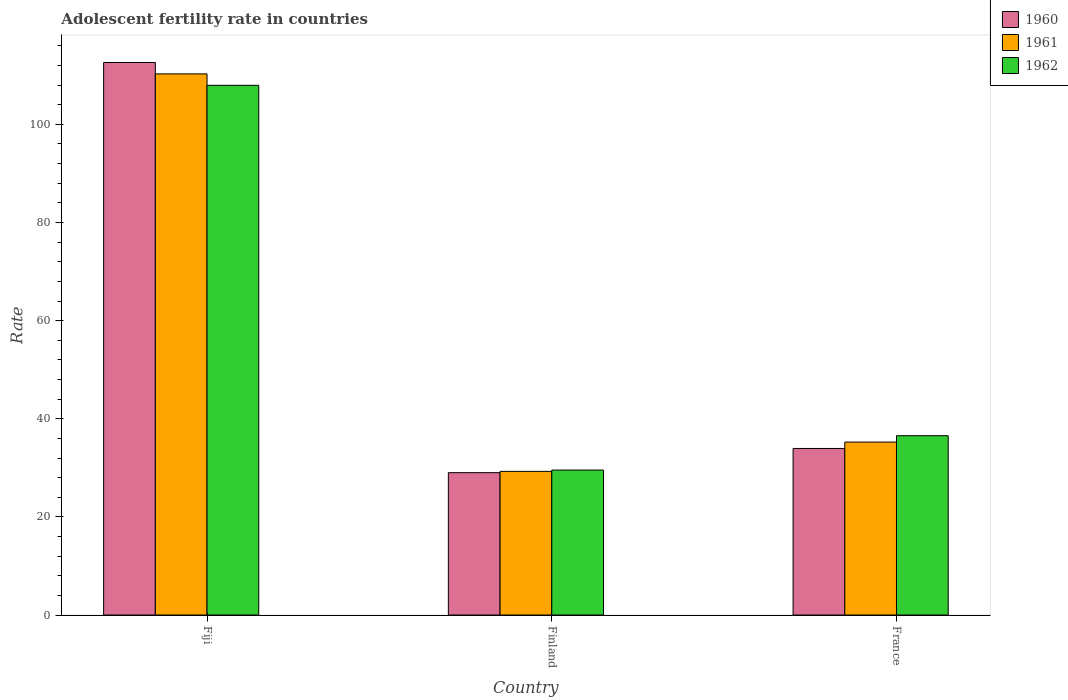How many different coloured bars are there?
Give a very brief answer. 3. How many groups of bars are there?
Offer a very short reply. 3. Are the number of bars on each tick of the X-axis equal?
Your answer should be very brief. Yes. What is the label of the 3rd group of bars from the left?
Make the answer very short. France. In how many cases, is the number of bars for a given country not equal to the number of legend labels?
Your answer should be very brief. 0. What is the adolescent fertility rate in 1960 in France?
Offer a terse response. 33.95. Across all countries, what is the maximum adolescent fertility rate in 1960?
Provide a succinct answer. 112.61. Across all countries, what is the minimum adolescent fertility rate in 1960?
Offer a very short reply. 29.01. In which country was the adolescent fertility rate in 1961 maximum?
Offer a terse response. Fiji. In which country was the adolescent fertility rate in 1961 minimum?
Ensure brevity in your answer.  Finland. What is the total adolescent fertility rate in 1960 in the graph?
Offer a terse response. 175.57. What is the difference between the adolescent fertility rate in 1960 in Fiji and that in Finland?
Give a very brief answer. 83.6. What is the difference between the adolescent fertility rate in 1962 in Fiji and the adolescent fertility rate in 1961 in Finland?
Keep it short and to the point. 78.69. What is the average adolescent fertility rate in 1962 per country?
Your answer should be very brief. 58.02. What is the difference between the adolescent fertility rate of/in 1960 and adolescent fertility rate of/in 1961 in Fiji?
Your answer should be compact. 2.32. In how many countries, is the adolescent fertility rate in 1960 greater than 68?
Provide a succinct answer. 1. What is the ratio of the adolescent fertility rate in 1960 in Finland to that in France?
Your answer should be very brief. 0.85. Is the adolescent fertility rate in 1960 in Fiji less than that in Finland?
Keep it short and to the point. No. What is the difference between the highest and the second highest adolescent fertility rate in 1960?
Give a very brief answer. 78.66. What is the difference between the highest and the lowest adolescent fertility rate in 1961?
Your answer should be compact. 81.01. In how many countries, is the adolescent fertility rate in 1961 greater than the average adolescent fertility rate in 1961 taken over all countries?
Your response must be concise. 1. Is the sum of the adolescent fertility rate in 1961 in Fiji and Finland greater than the maximum adolescent fertility rate in 1960 across all countries?
Keep it short and to the point. Yes. Is it the case that in every country, the sum of the adolescent fertility rate in 1960 and adolescent fertility rate in 1962 is greater than the adolescent fertility rate in 1961?
Make the answer very short. Yes. How many countries are there in the graph?
Ensure brevity in your answer.  3. What is the difference between two consecutive major ticks on the Y-axis?
Make the answer very short. 20. Are the values on the major ticks of Y-axis written in scientific E-notation?
Your answer should be compact. No. Where does the legend appear in the graph?
Your answer should be compact. Top right. How are the legend labels stacked?
Offer a terse response. Vertical. What is the title of the graph?
Provide a short and direct response. Adolescent fertility rate in countries. What is the label or title of the X-axis?
Provide a succinct answer. Country. What is the label or title of the Y-axis?
Keep it short and to the point. Rate. What is the Rate in 1960 in Fiji?
Provide a succinct answer. 112.61. What is the Rate in 1961 in Fiji?
Your answer should be very brief. 110.29. What is the Rate in 1962 in Fiji?
Provide a succinct answer. 107.96. What is the Rate of 1960 in Finland?
Offer a very short reply. 29.01. What is the Rate of 1961 in Finland?
Offer a terse response. 29.28. What is the Rate in 1962 in Finland?
Give a very brief answer. 29.54. What is the Rate in 1960 in France?
Keep it short and to the point. 33.95. What is the Rate of 1961 in France?
Your response must be concise. 35.25. What is the Rate of 1962 in France?
Offer a very short reply. 36.55. Across all countries, what is the maximum Rate of 1960?
Your answer should be compact. 112.61. Across all countries, what is the maximum Rate in 1961?
Keep it short and to the point. 110.29. Across all countries, what is the maximum Rate of 1962?
Your response must be concise. 107.96. Across all countries, what is the minimum Rate in 1960?
Your answer should be compact. 29.01. Across all countries, what is the minimum Rate of 1961?
Keep it short and to the point. 29.28. Across all countries, what is the minimum Rate of 1962?
Your response must be concise. 29.54. What is the total Rate in 1960 in the graph?
Your response must be concise. 175.57. What is the total Rate in 1961 in the graph?
Offer a terse response. 174.81. What is the total Rate of 1962 in the graph?
Keep it short and to the point. 174.05. What is the difference between the Rate of 1960 in Fiji and that in Finland?
Make the answer very short. 83.6. What is the difference between the Rate of 1961 in Fiji and that in Finland?
Offer a very short reply. 81.01. What is the difference between the Rate of 1962 in Fiji and that in Finland?
Make the answer very short. 78.42. What is the difference between the Rate in 1960 in Fiji and that in France?
Keep it short and to the point. 78.66. What is the difference between the Rate in 1961 in Fiji and that in France?
Keep it short and to the point. 75.04. What is the difference between the Rate in 1962 in Fiji and that in France?
Your answer should be very brief. 71.42. What is the difference between the Rate of 1960 in Finland and that in France?
Provide a succinct answer. -4.93. What is the difference between the Rate in 1961 in Finland and that in France?
Make the answer very short. -5.97. What is the difference between the Rate in 1962 in Finland and that in France?
Your answer should be very brief. -7. What is the difference between the Rate in 1960 in Fiji and the Rate in 1961 in Finland?
Offer a very short reply. 83.33. What is the difference between the Rate of 1960 in Fiji and the Rate of 1962 in Finland?
Ensure brevity in your answer.  83.07. What is the difference between the Rate of 1961 in Fiji and the Rate of 1962 in Finland?
Provide a succinct answer. 80.75. What is the difference between the Rate of 1960 in Fiji and the Rate of 1961 in France?
Keep it short and to the point. 77.36. What is the difference between the Rate of 1960 in Fiji and the Rate of 1962 in France?
Your answer should be very brief. 76.06. What is the difference between the Rate in 1961 in Fiji and the Rate in 1962 in France?
Offer a terse response. 73.74. What is the difference between the Rate in 1960 in Finland and the Rate in 1961 in France?
Give a very brief answer. -6.23. What is the difference between the Rate of 1960 in Finland and the Rate of 1962 in France?
Keep it short and to the point. -7.53. What is the difference between the Rate of 1961 in Finland and the Rate of 1962 in France?
Your answer should be compact. -7.27. What is the average Rate of 1960 per country?
Offer a terse response. 58.52. What is the average Rate in 1961 per country?
Provide a short and direct response. 58.27. What is the average Rate in 1962 per country?
Your answer should be very brief. 58.02. What is the difference between the Rate in 1960 and Rate in 1961 in Fiji?
Make the answer very short. 2.32. What is the difference between the Rate of 1960 and Rate of 1962 in Fiji?
Your answer should be very brief. 4.65. What is the difference between the Rate in 1961 and Rate in 1962 in Fiji?
Give a very brief answer. 2.32. What is the difference between the Rate in 1960 and Rate in 1961 in Finland?
Make the answer very short. -0.26. What is the difference between the Rate of 1960 and Rate of 1962 in Finland?
Provide a short and direct response. -0.53. What is the difference between the Rate in 1961 and Rate in 1962 in Finland?
Ensure brevity in your answer.  -0.26. What is the difference between the Rate of 1960 and Rate of 1961 in France?
Offer a very short reply. -1.3. What is the difference between the Rate in 1960 and Rate in 1962 in France?
Your answer should be very brief. -2.6. What is the difference between the Rate in 1961 and Rate in 1962 in France?
Provide a succinct answer. -1.3. What is the ratio of the Rate of 1960 in Fiji to that in Finland?
Your answer should be compact. 3.88. What is the ratio of the Rate of 1961 in Fiji to that in Finland?
Offer a very short reply. 3.77. What is the ratio of the Rate in 1962 in Fiji to that in Finland?
Your answer should be very brief. 3.65. What is the ratio of the Rate in 1960 in Fiji to that in France?
Provide a short and direct response. 3.32. What is the ratio of the Rate in 1961 in Fiji to that in France?
Provide a short and direct response. 3.13. What is the ratio of the Rate of 1962 in Fiji to that in France?
Provide a succinct answer. 2.95. What is the ratio of the Rate of 1960 in Finland to that in France?
Offer a terse response. 0.85. What is the ratio of the Rate of 1961 in Finland to that in France?
Provide a short and direct response. 0.83. What is the ratio of the Rate in 1962 in Finland to that in France?
Keep it short and to the point. 0.81. What is the difference between the highest and the second highest Rate in 1960?
Keep it short and to the point. 78.66. What is the difference between the highest and the second highest Rate in 1961?
Keep it short and to the point. 75.04. What is the difference between the highest and the second highest Rate in 1962?
Your answer should be very brief. 71.42. What is the difference between the highest and the lowest Rate in 1960?
Your answer should be very brief. 83.6. What is the difference between the highest and the lowest Rate in 1961?
Offer a very short reply. 81.01. What is the difference between the highest and the lowest Rate in 1962?
Your answer should be very brief. 78.42. 